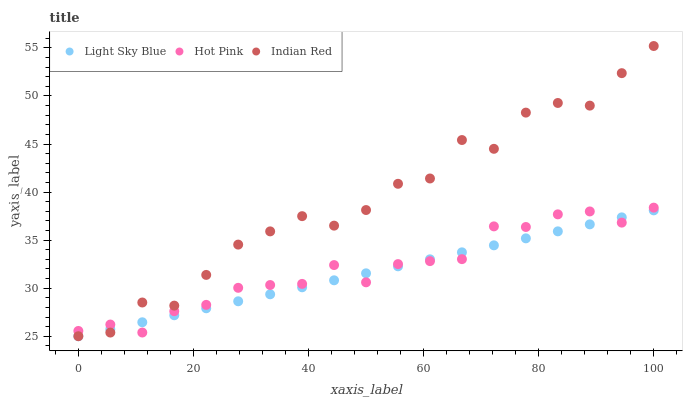Does Light Sky Blue have the minimum area under the curve?
Answer yes or no. Yes. Does Indian Red have the maximum area under the curve?
Answer yes or no. Yes. Does Hot Pink have the minimum area under the curve?
Answer yes or no. No. Does Hot Pink have the maximum area under the curve?
Answer yes or no. No. Is Light Sky Blue the smoothest?
Answer yes or no. Yes. Is Indian Red the roughest?
Answer yes or no. Yes. Is Hot Pink the smoothest?
Answer yes or no. No. Is Hot Pink the roughest?
Answer yes or no. No. Does Light Sky Blue have the lowest value?
Answer yes or no. Yes. Does Indian Red have the lowest value?
Answer yes or no. No. Does Indian Red have the highest value?
Answer yes or no. Yes. Does Hot Pink have the highest value?
Answer yes or no. No. Does Hot Pink intersect Indian Red?
Answer yes or no. Yes. Is Hot Pink less than Indian Red?
Answer yes or no. No. Is Hot Pink greater than Indian Red?
Answer yes or no. No. 